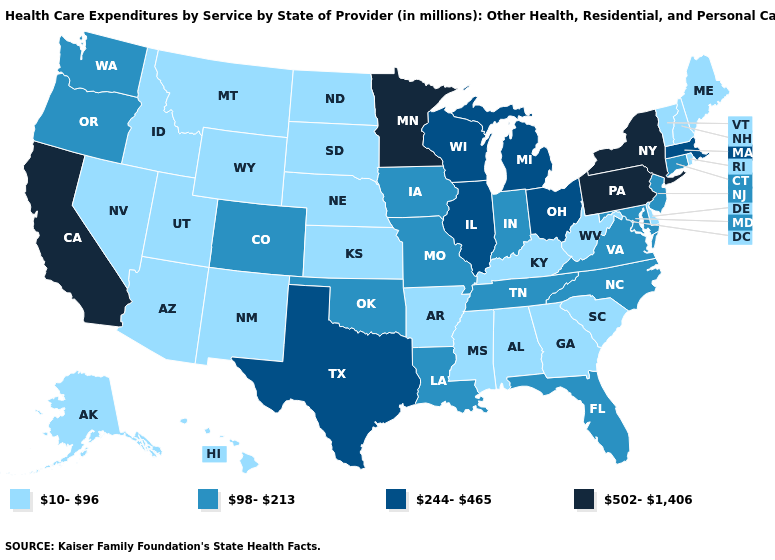What is the highest value in the South ?
Quick response, please. 244-465. Among the states that border Ohio , which have the lowest value?
Short answer required. Kentucky, West Virginia. Name the states that have a value in the range 502-1,406?
Keep it brief. California, Minnesota, New York, Pennsylvania. Name the states that have a value in the range 10-96?
Keep it brief. Alabama, Alaska, Arizona, Arkansas, Delaware, Georgia, Hawaii, Idaho, Kansas, Kentucky, Maine, Mississippi, Montana, Nebraska, Nevada, New Hampshire, New Mexico, North Dakota, Rhode Island, South Carolina, South Dakota, Utah, Vermont, West Virginia, Wyoming. What is the value of Oregon?
Answer briefly. 98-213. Name the states that have a value in the range 98-213?
Quick response, please. Colorado, Connecticut, Florida, Indiana, Iowa, Louisiana, Maryland, Missouri, New Jersey, North Carolina, Oklahoma, Oregon, Tennessee, Virginia, Washington. What is the lowest value in the MidWest?
Short answer required. 10-96. What is the highest value in the USA?
Be succinct. 502-1,406. How many symbols are there in the legend?
Write a very short answer. 4. What is the value of Wyoming?
Write a very short answer. 10-96. What is the highest value in the MidWest ?
Answer briefly. 502-1,406. Name the states that have a value in the range 502-1,406?
Concise answer only. California, Minnesota, New York, Pennsylvania. What is the highest value in the USA?
Give a very brief answer. 502-1,406. Name the states that have a value in the range 98-213?
Write a very short answer. Colorado, Connecticut, Florida, Indiana, Iowa, Louisiana, Maryland, Missouri, New Jersey, North Carolina, Oklahoma, Oregon, Tennessee, Virginia, Washington. Among the states that border Utah , which have the lowest value?
Write a very short answer. Arizona, Idaho, Nevada, New Mexico, Wyoming. 